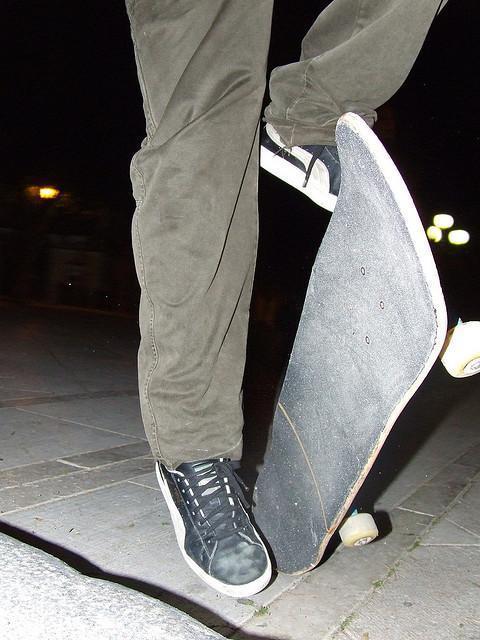How many wheels on the skateboard?
Give a very brief answer. 4. How many dogs are there with brown color?
Give a very brief answer. 0. 